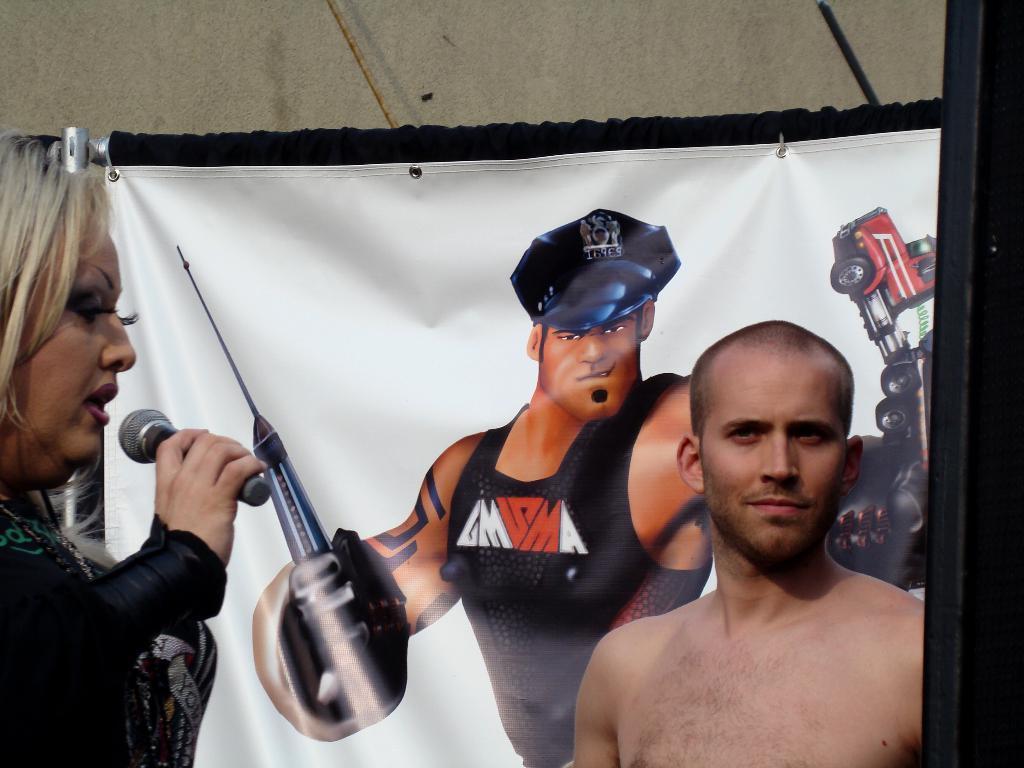How would you summarize this image in a sentence or two? A shirtless man is on the right side of the image. A lady with a mic in her hand is talking to him. In the background there is a poster of a man who has truck in one hand and a tool in his other hand. This is fixed to the wall 